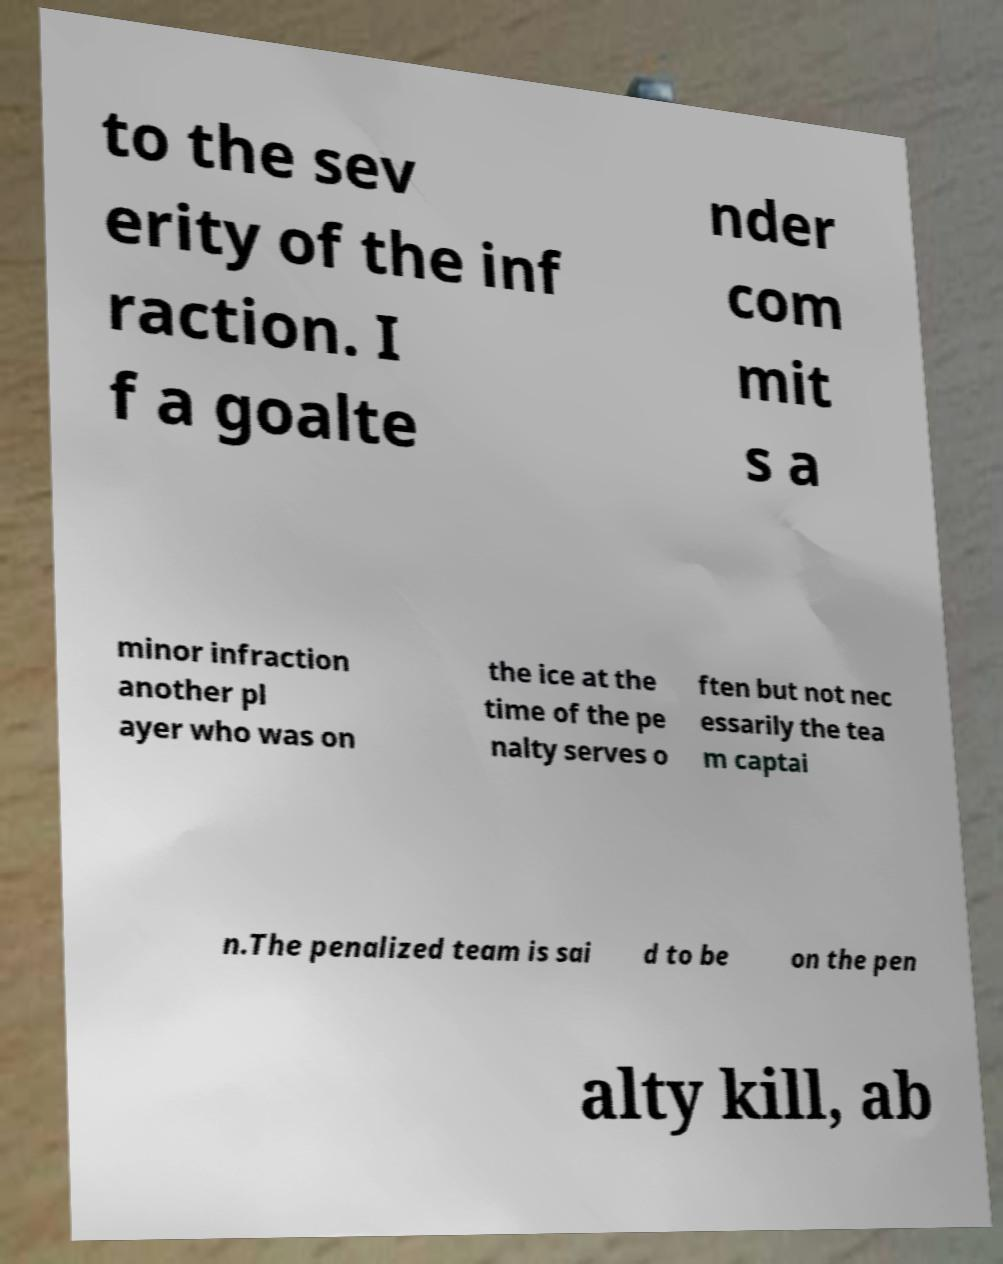What messages or text are displayed in this image? I need them in a readable, typed format. to the sev erity of the inf raction. I f a goalte nder com mit s a minor infraction another pl ayer who was on the ice at the time of the pe nalty serves o ften but not nec essarily the tea m captai n.The penalized team is sai d to be on the pen alty kill, ab 